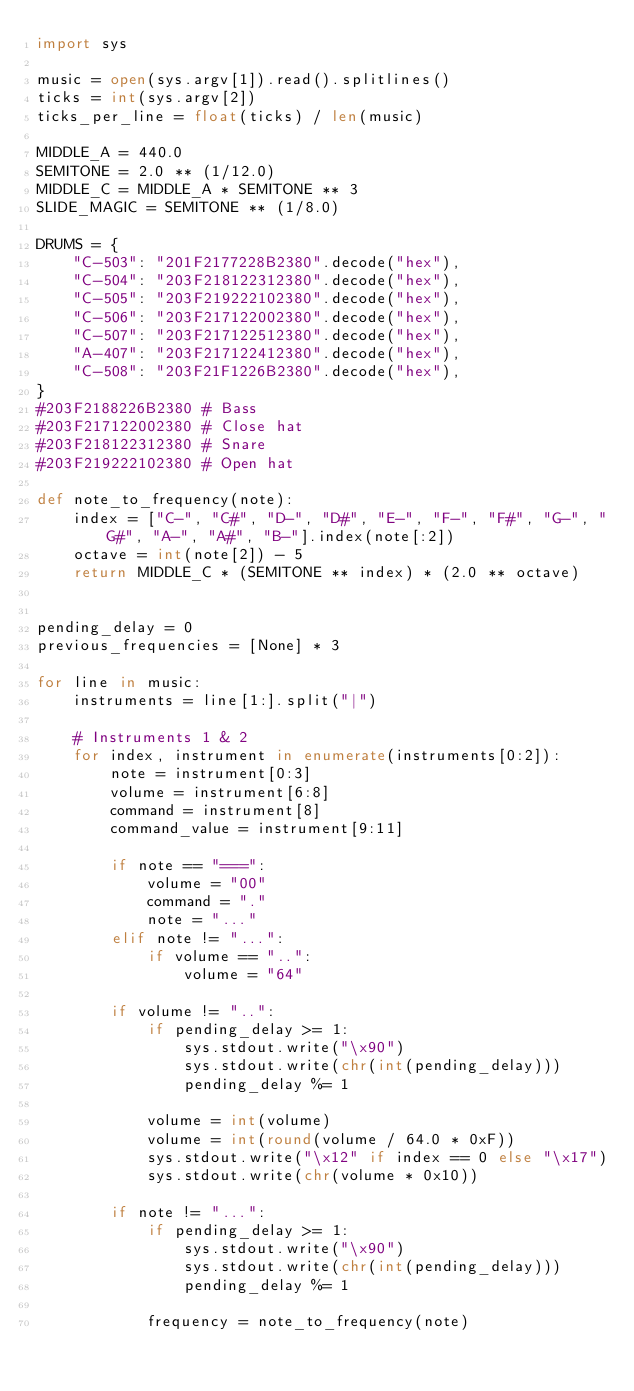<code> <loc_0><loc_0><loc_500><loc_500><_Python_>import sys

music = open(sys.argv[1]).read().splitlines()
ticks = int(sys.argv[2])
ticks_per_line = float(ticks) / len(music)

MIDDLE_A = 440.0
SEMITONE = 2.0 ** (1/12.0)
MIDDLE_C = MIDDLE_A * SEMITONE ** 3
SLIDE_MAGIC = SEMITONE ** (1/8.0)

DRUMS = {
    "C-503": "201F2177228B2380".decode("hex"),
    "C-504": "203F218122312380".decode("hex"),
    "C-505": "203F219222102380".decode("hex"),
    "C-506": "203F217122002380".decode("hex"),
    "C-507": "203F217122512380".decode("hex"),
    "A-407": "203F217122412380".decode("hex"),
    "C-508": "203F21F1226B2380".decode("hex"),
}
#203F2188226B2380 # Bass
#203F217122002380 # Close hat
#203F218122312380 # Snare
#203F219222102380 # Open hat

def note_to_frequency(note):
    index = ["C-", "C#", "D-", "D#", "E-", "F-", "F#", "G-", "G#", "A-", "A#", "B-"].index(note[:2])
    octave = int(note[2]) - 5
    return MIDDLE_C * (SEMITONE ** index) * (2.0 ** octave)


pending_delay = 0
previous_frequencies = [None] * 3

for line in music:
    instruments = line[1:].split("|")

    # Instruments 1 & 2
    for index, instrument in enumerate(instruments[0:2]):
        note = instrument[0:3]
        volume = instrument[6:8]
        command = instrument[8]
        command_value = instrument[9:11]

        if note == "===":
            volume = "00"
            command = "."
            note = "..."
        elif note != "...":
            if volume == "..":
                volume = "64"

        if volume != "..":
            if pending_delay >= 1:
                sys.stdout.write("\x90")
                sys.stdout.write(chr(int(pending_delay)))
                pending_delay %= 1

            volume = int(volume)
            volume = int(round(volume / 64.0 * 0xF))
            sys.stdout.write("\x12" if index == 0 else "\x17")
            sys.stdout.write(chr(volume * 0x10))

        if note != "...":
            if pending_delay >= 1:
                sys.stdout.write("\x90")
                sys.stdout.write(chr(int(pending_delay)))
                pending_delay %= 1

            frequency = note_to_frequency(note)</code> 